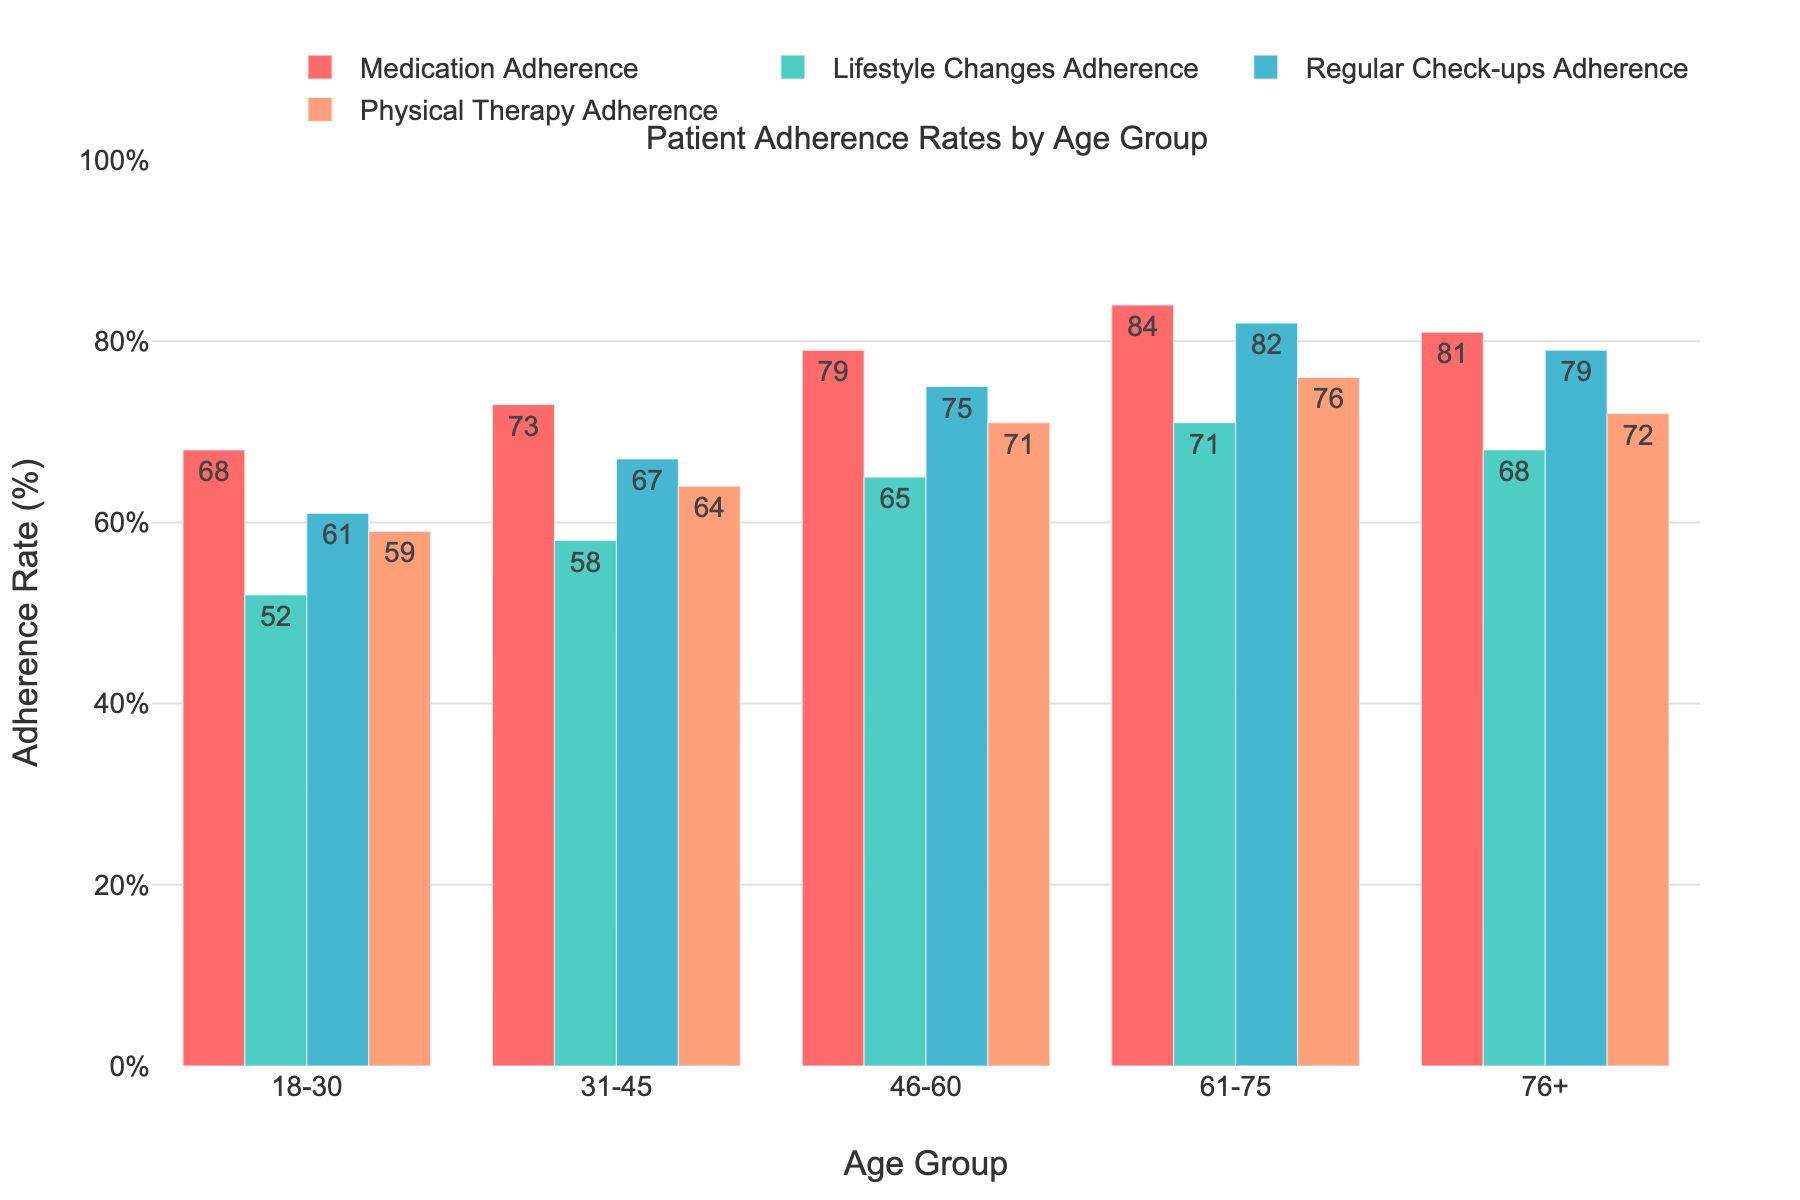Which age group has the highest adherence to medication? The bar chart shows adherence rates for different age groups. By visually examining the bars for medication adherence, the 61-75 age group has the highest bar.
Answer: 61-75 What is the difference in regular check-ups adherence between the 18-30 and 46-60 age groups? Look at the height of the bars for "Regular Check-ups Adherence" for the age groups 18-30 and 46-60. The 18-30 group has an adherence rate of 61, and the 46-60 group has a rate of 75. The difference is 75 - 61 = 14.
Answer: 14 Which adherence type has the largest drop in adherence rate between the 31-45 and 76+ age groups? Compare the adherence rates for each category (Medication, Lifestyle Changes, Regular Check-ups, Physical Therapy) between the 31-45 and 76+ age groups. Calculate the difference for each category: 
- Medication: 73 - 81 = -8
- Lifestyle Changes: 58 - 68 = -10
- Regular Check-ups: 67 - 79 = -12
- Physical Therapy: 64 - 72 = -8
The largest drop is in "Regular Check-ups Adherence" with a difference of -12.
Answer: Regular Check-ups Adherence What is the average adherence rate for lifestyle changes across all age groups? Add all the adherence rates for lifestyle changes and divide by the number of age groups. The rates are 52, 58, 65, 71, and 68. Calculate the sum: 52 + 58 + 65 + 71 + 68 = 314. Divide by the number of age groups (5): 314 ÷ 5 = 62.8.
Answer: 62.8 Which adherence category shows the most consistent rates across the different age groups? By visually examining the variability in the heights of the bars for each adherence category, Lifestyle Changes Adherence shows the most consistent pattern. The rates are fairly close without large fluctuations.
Answer: Lifestyle Changes Adherence 